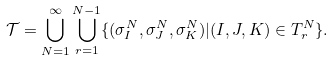<formula> <loc_0><loc_0><loc_500><loc_500>\mathcal { T } = \bigcup _ { N = 1 } ^ { \infty } \bigcup _ { r = 1 } ^ { N - 1 } \{ ( \sigma _ { I } ^ { N } , \sigma _ { J } ^ { N } , \sigma _ { K } ^ { N } ) | ( I , J , K ) \in T ^ { N } _ { r } \} .</formula> 